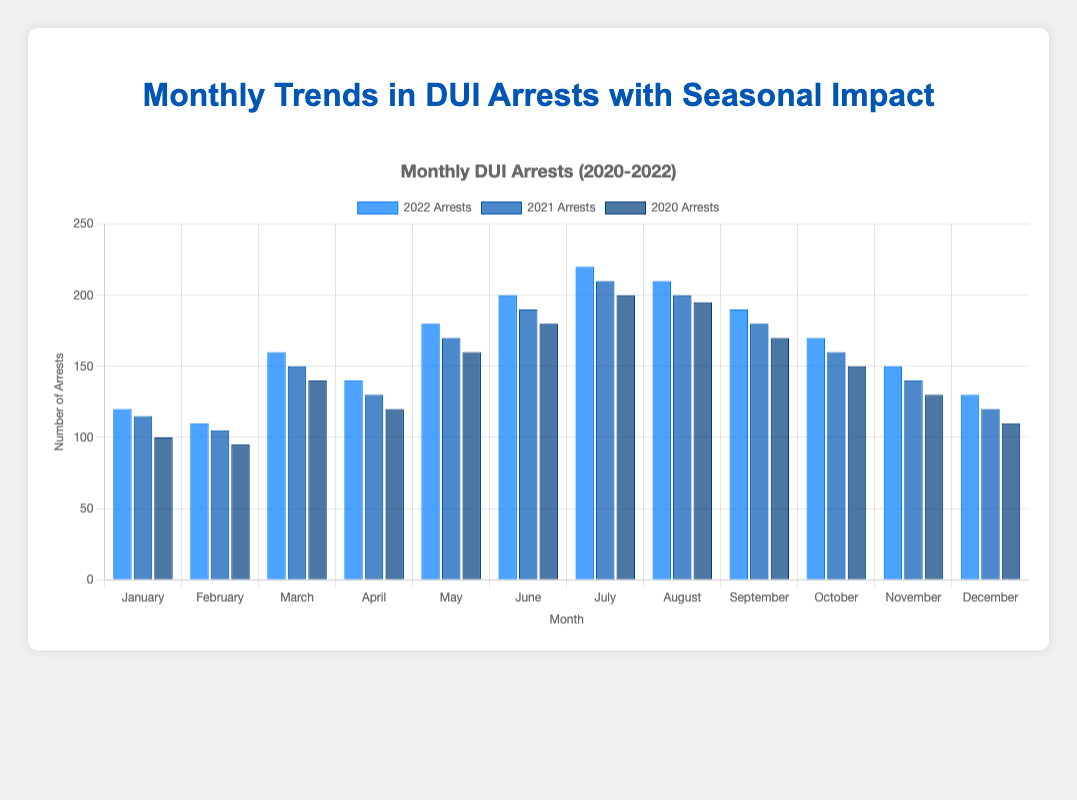What month in 2022 had the highest number of DUI arrests? In 2022, the tallest bar indicates the highest number of arrests, which is July with 220 arrests.
Answer: July How do DUI arrests in December 2021 compare to those in December 2020? The bar for December 2021 reaches 120 arrests, while the bar for December 2020 reaches 110 arrests, indicating that December 2021 had 10 more arrests.
Answer: 10 more arrests in December 2021 What was the average number of DUI arrests for the summer months (June, July, August) in 2022? For the summer months in 2022, the DUI arrests are: June (200), July (220), and August (210). The average is calculated as (200 + 220 + 210) / 3 = 210.
Answer: 210 Which year shows the largest decrease in DUI arrests from July to August, and by how many arrests? From the chart, in 2022, the decrease is 220 - 210 = 10; in 2021, the decrease is 210 - 200 = 10; in 2020, the decrease is 200 - 195 = 5. Both 2021 and 2022 show the largest decrease of 10 arrests.
Answer: 2021 and 2022, decrease by 10 arrests What is the total number of DUI arrests in the year 2021? Sum all the bars for each month in 2021: 115 + 105 + 150 + 130 + 170 + 190 + 210 + 200 + 180 + 160 + 140 + 120 = 1870.
Answer: 1870 Compare the general trend of DUI arrests from January to December in 2022. Does it show an increasing or decreasing pattern? From January (120 arrests) to December (130 arrests), the chart shows fluctuations but generally ends with slightly higher arrests in December compared to January.
Answer: Slightly increasing pattern In which month was the seasonal adjustment highest for the year 2020, and what was its value? The tallest bar for seasonal adjustment in 2020 appears in July, with a value of 26.
Answer: July, 26 Which months in 2021 had the same number of DUI arrests? The chart shows that the height of bars for June and August in 2021 is equal, both having 200 arrests.
Answer: June and August What is the difference in DUI arrests between March 2022 and March 2020? In March 2022, there were 160 arrests, and in March 2020, there were 140 arrests. The difference is 160 - 140 = 20.
Answer: 20 Does the number of DUI arrests in January each year increase, decrease, or remain the same from 2020 to 2022? The number of DUI arrests in January for each year is: 2020 (100), 2021 (115), and 2022 (120). It shows an increasing trend each year.
Answer: Increasing 